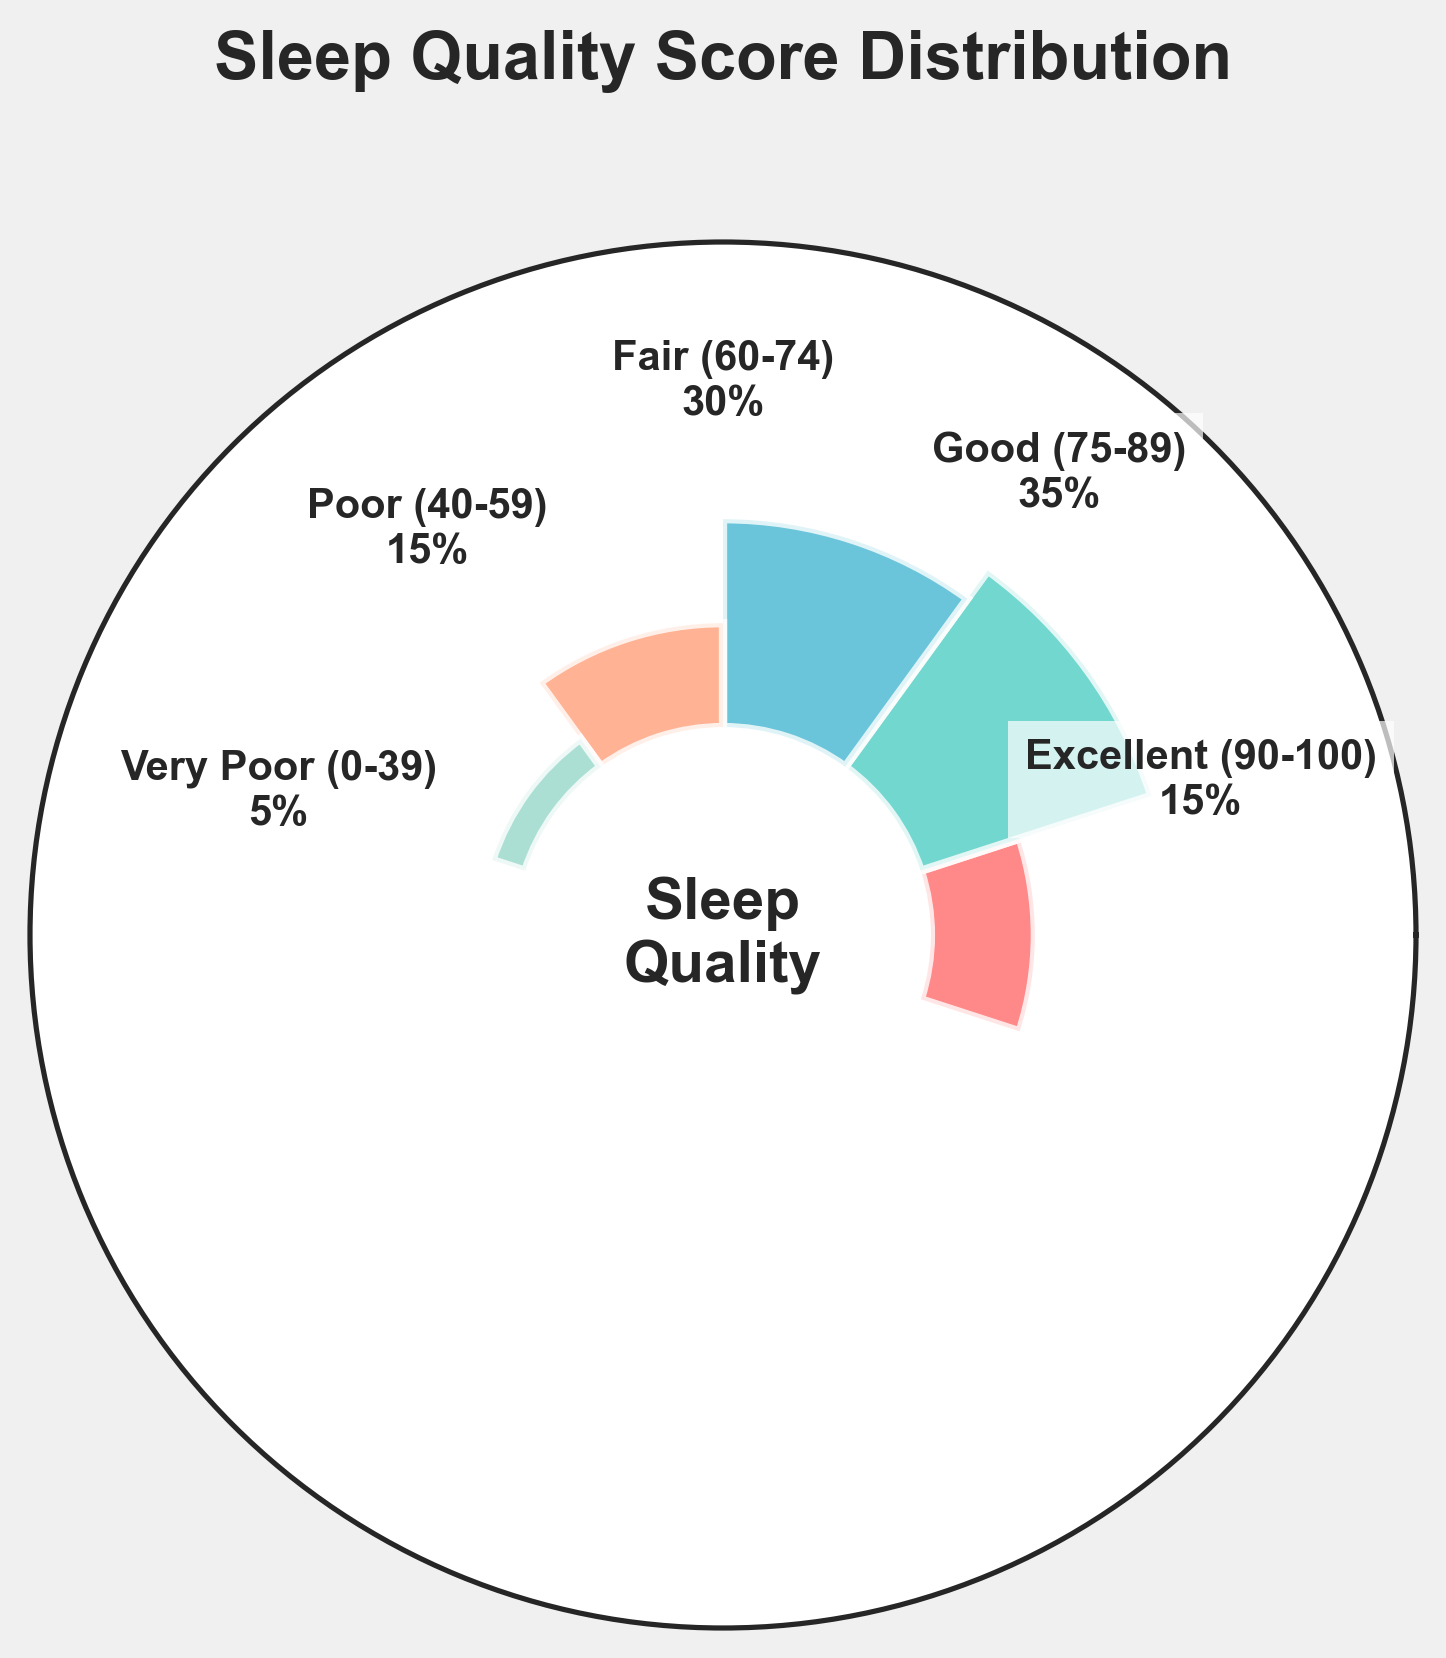what is the title of the gauge chart? The title is centrally placed at the top of the figure. It is easy to identify as "Sleep Quality Score Distribution".
Answer: Sleep Quality Score Distribution How many sleep quality categories are represented in the chart? By counting the different segments or categories labeled on the chart, we can see there are five distinct categories.
Answer: five Which sleep quality category has the highest percentage? By observing the size and positioning of the bars, we can identify that the 'Good (75-89)' sleep quality category occupies the largest portion, indicating it has the highest percentage.
Answer: Good (75-89) What percentage of users fall into the 'Fair (60-74)' sleep quality category? The label on the corresponding segment of the chart indicates the percentage. The value inside the 'Fair (60-74)' segment is 30%.
Answer: 30% What is the combined percentage of users with 'Poor (40-59)' or 'Very Poor (0-39)' sleep quality? We need to add the percentages of the 'Poor (40-59)' and 'Very Poor (0-39)' categories. From the chart, 'Poor (40-59)' is 15%, and 'Very Poor (0-39)' is 5%. Adding them together gives 15% + 5% = 20%.
Answer: 20% Which sleep quality category has the lowest percentage? By observing the relative sizes of the segments, the 'Very Poor (0-39)' category is the smallest, indicating it has the lowest percentage.
Answer: Very Poor (0-39) Are more users in the 'Excellent (90-100)' category or the 'Poor (40-59)' category? By comparing the percentages, we see both 'Excellent (90-100)' and 'Poor (40-59)' each have 15%. Thus, the number of users in both categories is equal.
Answer: They are equal What is the difference in percentage between the 'Good (75-89)' and 'Fair (60-74)' categories? The 'Good (75-89)' category is 35%, and the 'Fair (60-74)' category is 30%. Subtracting these gives 35% - 30% = 5%.
Answer: 5% What percentage of users have a sleep quality score of 60 or higher? This includes the categories 'Fair (60-74)', 'Good (75-89)', and 'Excellent (90-100)'. Adding their percentages: 30% (Fair) + 35% (Good) + 15% (Excellent) = 80%.
Answer: 80% Which group, 'Fair (60-74)' or 'Excellent (90-100)', has a higher percentage of users? By comparing the labels on the chart, 'Fair (60-74)' has 30% and 'Excellent (90-100)' has 15%. Therefore, 'Fair (60-74)' has the higher percentage.
Answer: Fair (60-74) 